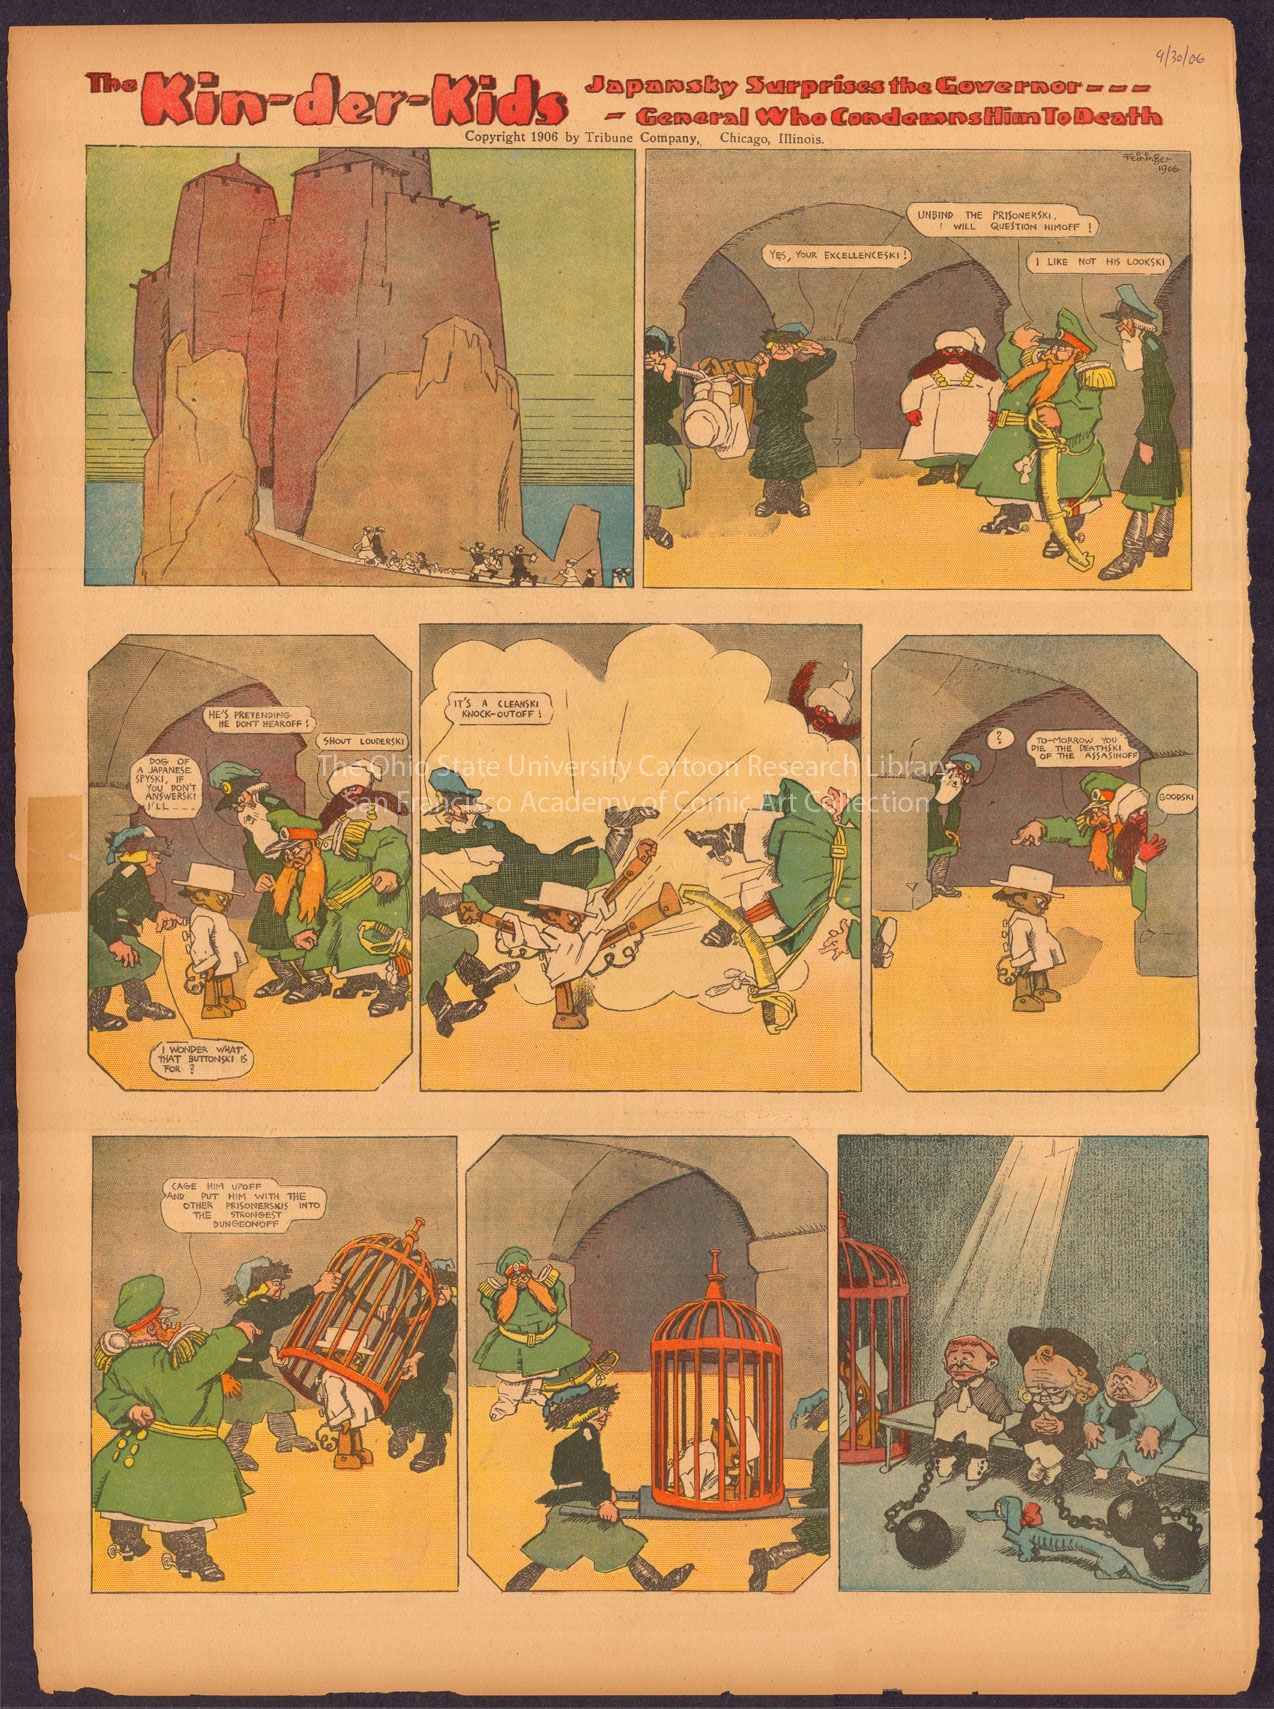Describe the following image. The image features a vintage comic strip titled 'The Kin-der-Kids', dating from 1906. It's an early example of a Sunday comic strip, created by cartoonist Lyonel Feininger for the Chicago Sunday Tribune. The narrative, spread over six panels, showcases quirky and exaggerated characters in absurd, sometimes surreal adventures that were characteristic of the imaginative storytelling popular in early comics. The title 'Japanese by Surprise the Governor - - General Who Condemns Man To Death', hints at the humorous and political undertones of the episode. Vivid and diverse coloration is used in the scenes, and texts in speech bubbles reveal dialogue, emotion, and context, contributing to the story’s comprehension. This strip reflects the blend of social commentary and whimsy that was common in the period's cartoon strips. 